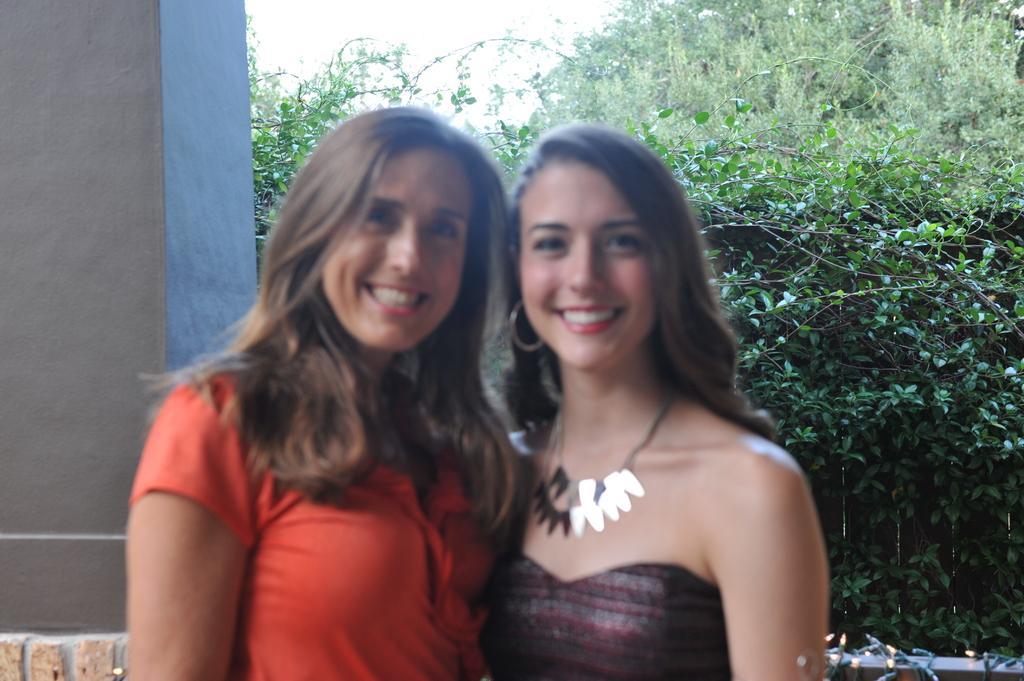In one or two sentences, can you explain what this image depicts? In this image, we can see two persons wearing clothes. There is a wall on the left side of the image. In the background of the image, there are some plants and trees. 